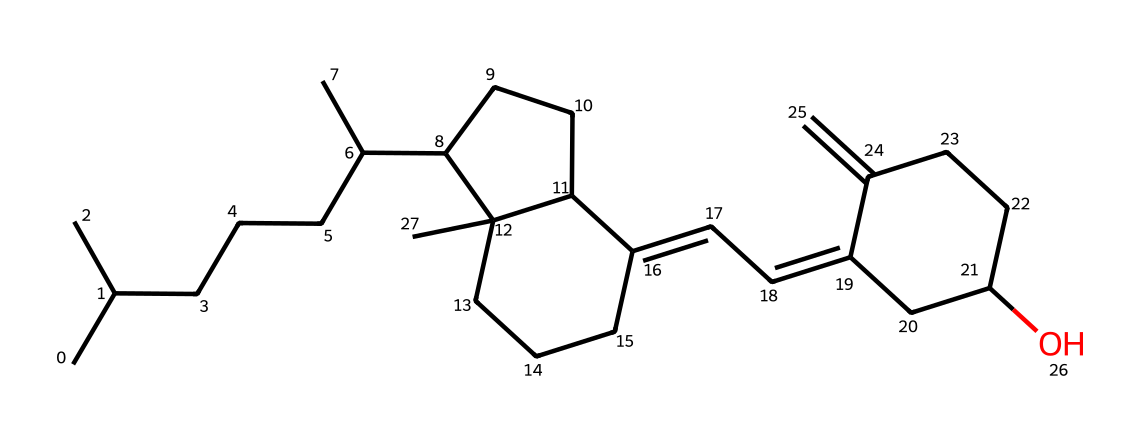What is the name of this chemical? The provided SMILES representation corresponds to cholecalciferol, commonly known as vitamin D3. This can be determined by recognizing the carbon skeleton and comparing it to known structures of vitamin D compounds.
Answer: cholecalciferol How many carbon atoms are in the molecule? To find the number of carbon atoms, one can count the 'C' symbols in the SMILES representation, which indicates each carbon atom. Upon counting, there are a total of 27 carbon atoms in this molecule.
Answer: 27 Does this molecule contain functional groups? The structure includes a hydroxyl group (-OH) indicated by the 'O' in the SMILES, which is characteristic of alcohols. Therefore, we can identify the presence of functional groups by looking for elements like oxygen and their connectivity in the structure.
Answer: Yes What type of compound is cholecalciferol? Cholecalciferol is classified as a secosteroid, which is a subclass of steroid compounds that contain a broken ring structure. Observing the structure shows that it has the non-aromatic ring characteristic of steroids while also having at least one open bond indicating a secosteroid.
Answer: secosteroid Does this molecule have any double bonds? By examining the SMILES, we can identify double bonds in the structure denoted by the '=' symbol. These double bonds can be found in various positions within the carbon skeleton, indicating unsaturation in the organic compound.
Answer: Yes 